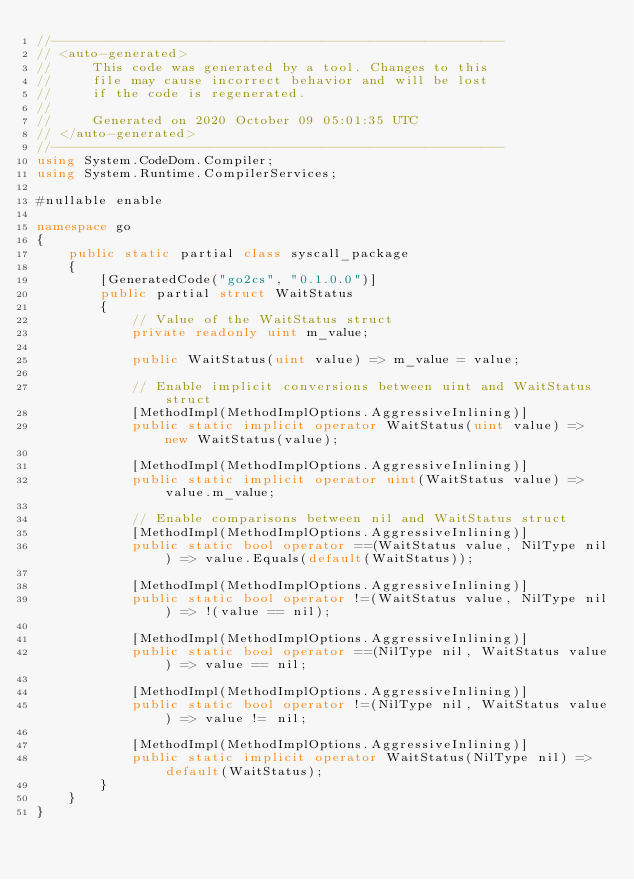<code> <loc_0><loc_0><loc_500><loc_500><_C#_>//---------------------------------------------------------
// <auto-generated>
//     This code was generated by a tool. Changes to this
//     file may cause incorrect behavior and will be lost
//     if the code is regenerated.
//
//     Generated on 2020 October 09 05:01:35 UTC
// </auto-generated>
//---------------------------------------------------------
using System.CodeDom.Compiler;
using System.Runtime.CompilerServices;

#nullable enable

namespace go
{
    public static partial class syscall_package
    {
        [GeneratedCode("go2cs", "0.1.0.0")]
        public partial struct WaitStatus
        {
            // Value of the WaitStatus struct
            private readonly uint m_value;

            public WaitStatus(uint value) => m_value = value;

            // Enable implicit conversions between uint and WaitStatus struct
            [MethodImpl(MethodImplOptions.AggressiveInlining)]
            public static implicit operator WaitStatus(uint value) => new WaitStatus(value);
            
            [MethodImpl(MethodImplOptions.AggressiveInlining)]
            public static implicit operator uint(WaitStatus value) => value.m_value;
            
            // Enable comparisons between nil and WaitStatus struct
            [MethodImpl(MethodImplOptions.AggressiveInlining)]
            public static bool operator ==(WaitStatus value, NilType nil) => value.Equals(default(WaitStatus));

            [MethodImpl(MethodImplOptions.AggressiveInlining)]
            public static bool operator !=(WaitStatus value, NilType nil) => !(value == nil);

            [MethodImpl(MethodImplOptions.AggressiveInlining)]
            public static bool operator ==(NilType nil, WaitStatus value) => value == nil;

            [MethodImpl(MethodImplOptions.AggressiveInlining)]
            public static bool operator !=(NilType nil, WaitStatus value) => value != nil;

            [MethodImpl(MethodImplOptions.AggressiveInlining)]
            public static implicit operator WaitStatus(NilType nil) => default(WaitStatus);
        }
    }
}
</code> 